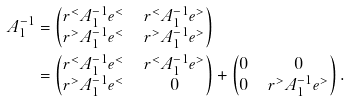Convert formula to latex. <formula><loc_0><loc_0><loc_500><loc_500>A _ { 1 } ^ { - 1 } & = \begin{pmatrix} r ^ { < } A _ { 1 } ^ { - 1 } e ^ { < } & \, r ^ { < } A _ { 1 } ^ { - 1 } e ^ { > } \\ r ^ { > } A _ { 1 } ^ { - 1 } e ^ { < } & \, r ^ { > } A _ { 1 } ^ { - 1 } e ^ { > } \end{pmatrix} \\ & = \begin{pmatrix} r ^ { < } A _ { 1 } ^ { - 1 } e ^ { < } & \, r ^ { < } A _ { 1 } ^ { - 1 } e ^ { > } \\ r ^ { > } A _ { 1 } ^ { - 1 } e ^ { < } & \, 0 \end{pmatrix} + \begin{pmatrix} 0 & \, 0 \\ 0 & \, r ^ { > } A _ { 1 } ^ { - 1 } e ^ { > } \end{pmatrix} .</formula> 